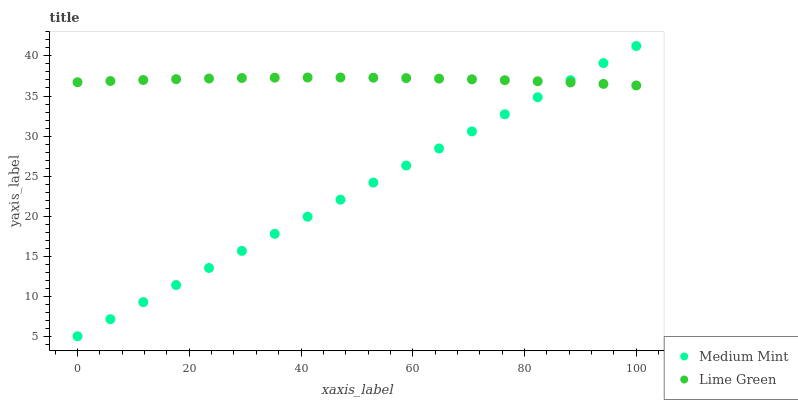Does Medium Mint have the minimum area under the curve?
Answer yes or no. Yes. Does Lime Green have the maximum area under the curve?
Answer yes or no. Yes. Does Lime Green have the minimum area under the curve?
Answer yes or no. No. Is Medium Mint the smoothest?
Answer yes or no. Yes. Is Lime Green the roughest?
Answer yes or no. Yes. Is Lime Green the smoothest?
Answer yes or no. No. Does Medium Mint have the lowest value?
Answer yes or no. Yes. Does Lime Green have the lowest value?
Answer yes or no. No. Does Medium Mint have the highest value?
Answer yes or no. Yes. Does Lime Green have the highest value?
Answer yes or no. No. Does Lime Green intersect Medium Mint?
Answer yes or no. Yes. Is Lime Green less than Medium Mint?
Answer yes or no. No. Is Lime Green greater than Medium Mint?
Answer yes or no. No. 